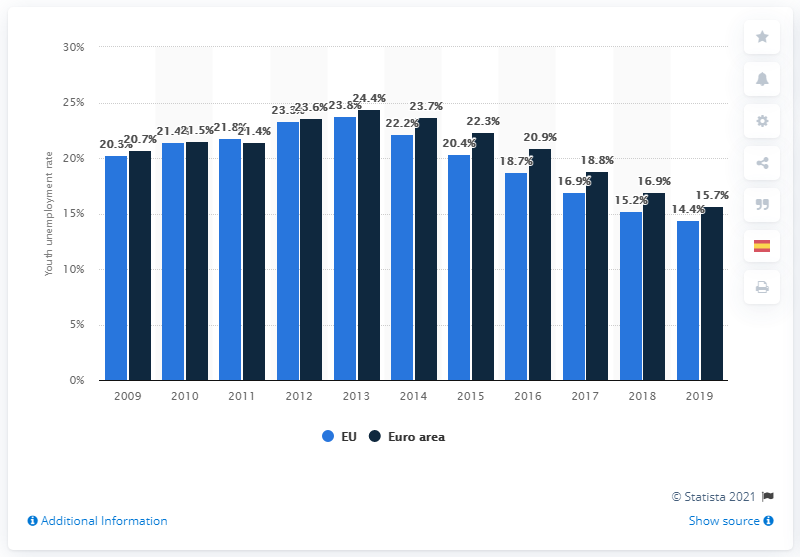List a handful of essential elements in this visual. In 2019, the youth unemployment rate in the European Union was 15.7%. 